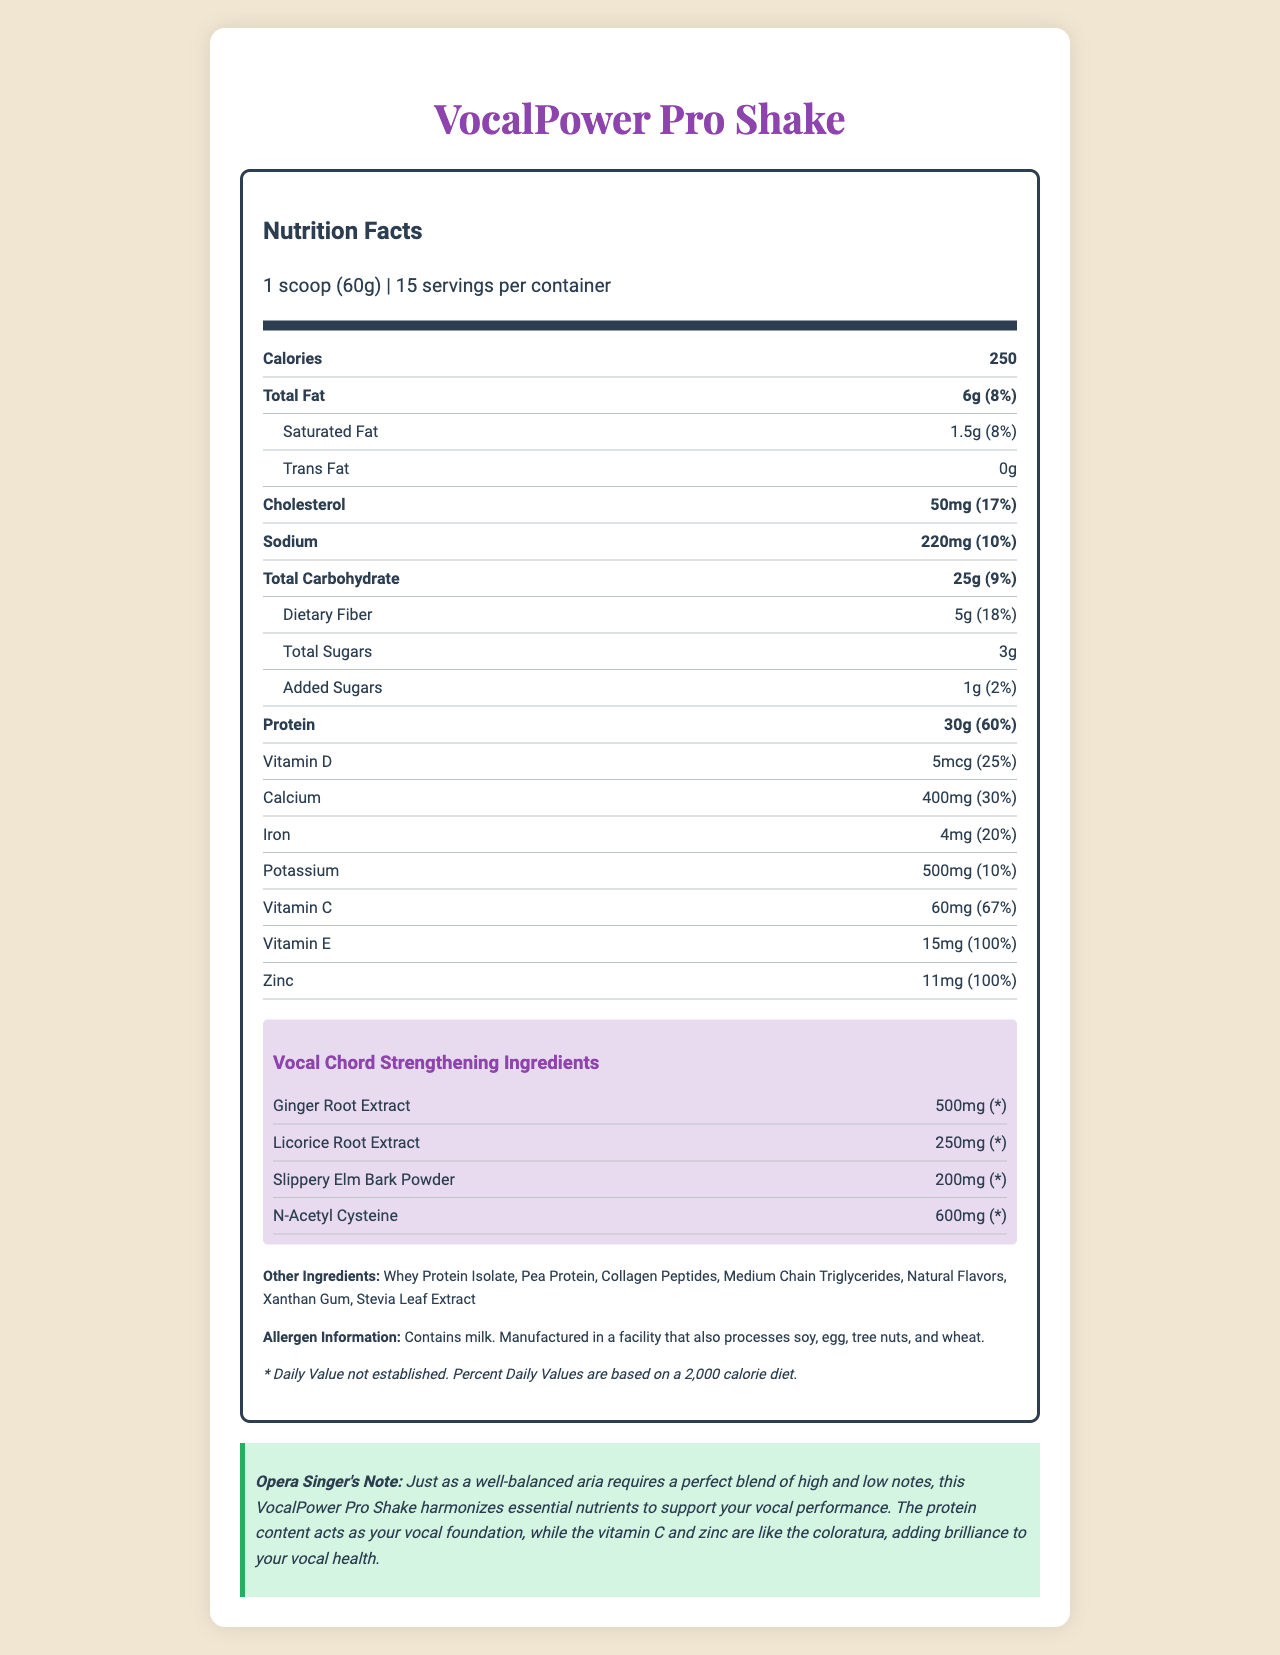What is the serving size of VocalPower Pro Shake? The serving size is specified near the top of the nutrition label as "1 scoop (60g)".
Answer: 1 scoop (60g) How many servings are there per container of VocalPower Pro Shake? The servings per container are explicitly mentioned as 15 in the document.
Answer: 15 What is the total amount of protein per serving? The amount of protein per serving is given as 30g in the document.
Answer: 30g What percentage of the daily value for fiber does one serving provide? The document states that the dietary fiber in one serving amounts to 18% of the daily value.
Answer: 18% Name one of the vocal chord-strengthening ingredients in the shake. The document lists four vocal chord-strengthening ingredients, one of which is Ginger Root Extract.
Answer: Ginger Root Extract Which of the following is not an ingredient in the shake? A. Pea Protein B. Casein C. Xanthan Gum D. Collagen Peptides The list of other ingredients includes Pea Protein, Xanthan Gum, and Collagen Peptides but not Casein.
Answer: B What is the amount of Vitamin C included per serving? A. 30mg B. 60mg C. 15mg D. 100mg The label specifies that each serving contains 60mg of Vitamin C.
Answer: B Is there any cholesterol in VocalPower Pro Shake? The document states that there are 50mg of cholesterol per serving.
Answer: Yes Summarize the key nutritional information and ingredients of the VocalPower Pro Shake. This summary captures the major nutritional components and emphasizes the vocal chord-strengthening ingredients and the allergen information.
Answer: The VocalPower Pro Shake offers 30g of protein per serving along with significant amounts of vitamins C, D, and E, calcium, iron, and zinc. It contains ingredients known to support vocal health, including Ginger Root Extract, Licorice Root Extract, Slippery Elm Bark Powder, and N-Acetyl Cysteine. The shake also lists other components such as Whey Protein Isolate, Pea Protein, and Medium Chain Triglycerides, and it contains allergens like milk. What are the flavors of VocalPower Pro Shake? The document does not list specific flavors of the VocalPower Pro Shake.
Answer: Not enough information How much calcium is in one serving? The nutrition label indicates that each serving contains 400mg of calcium.
Answer: 400mg How many grams of total sugars are included per serving, and what percentage of them are added sugars? The document specifies that there are 3g of total sugars per serving, with 1g being added sugars, accounting for 2% of the daily value.
Answer: 3g total sugars, with 1g being added sugars (2% daily value) Does the shake contain any dietary fiber? The document lists 5g of dietary fiber per serving.
Answer: Yes Which ingredient is included at 600mg in each serving? A. Ginger Root Extract B. Licorice Root Extract C. Slippery Elm Bark Powder D. N-Acetyl Cysteine The label indicates that N-Acetyl Cysteine is included in the shake at 600mg per serving.
Answer: D Is there any mention of the facility where this product is manufactured? The label mentions that the shake is manufactured in a facility that processes soy, egg, tree nuts, and wheat.
Answer: Yes 